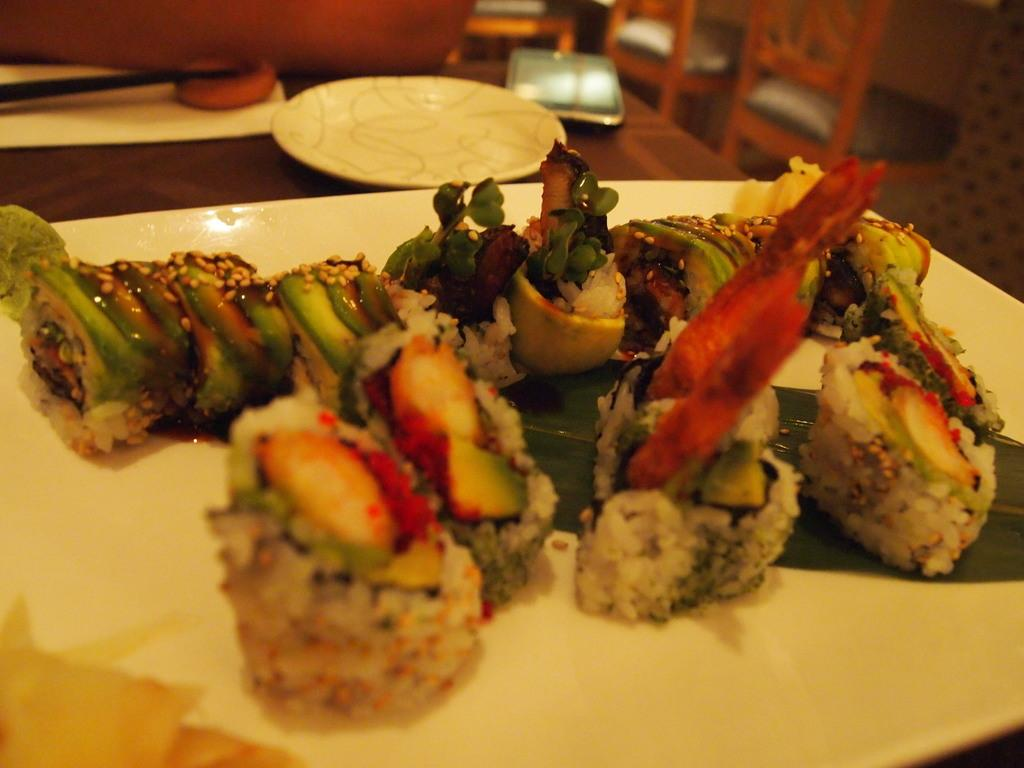What is on the plate that is visible in the image? There is food in the plate in the image. Where is the other plate located in the image? There is a plate in the background of the image. What else can be seen in the background of the image? There is a mobile, chairs, and a wall in the background of the image. Reasoning: Let'g: Let's think step by step in order to produce the conversation. We start by identifying the main subject in the image, which is the plate with food. Then, we expand the conversation to include other items that are also visible in the background, such as the second plate, the mobile, chairs, and the wall. Each question is designed to elicit a specific detail about the image that is known from the provided facts. Absurd Question/Answer: What type of plants are growing on the moon in the image? There are no plants or references to the moon in the image; it features a plate with food and various items in the background. 